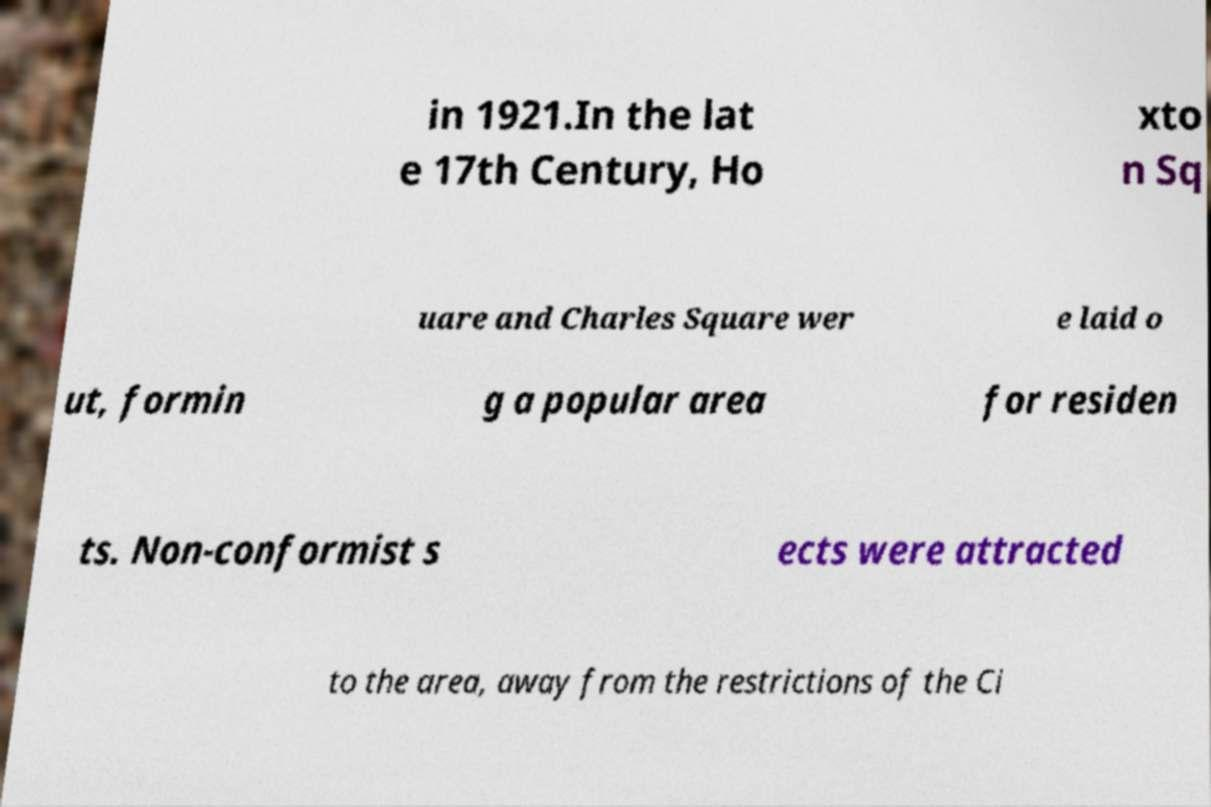There's text embedded in this image that I need extracted. Can you transcribe it verbatim? in 1921.In the lat e 17th Century, Ho xto n Sq uare and Charles Square wer e laid o ut, formin g a popular area for residen ts. Non-conformist s ects were attracted to the area, away from the restrictions of the Ci 